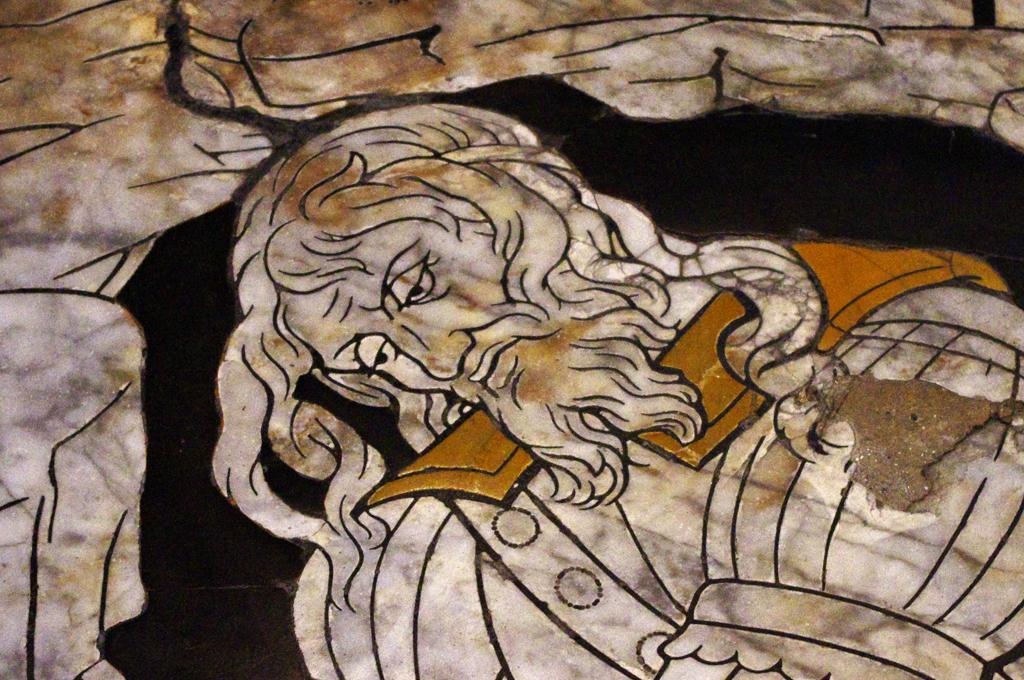What is the main subject of the image? There is a painting in the image. What is depicted in the painting? The painting depicts a person. What colors are used in the painting? The painting's colors include cream, brown, black, and white. What type of music is being played by the committee in the image? There is no mention of music, a committee, or any sound in the image; it only features a painting of a person. 